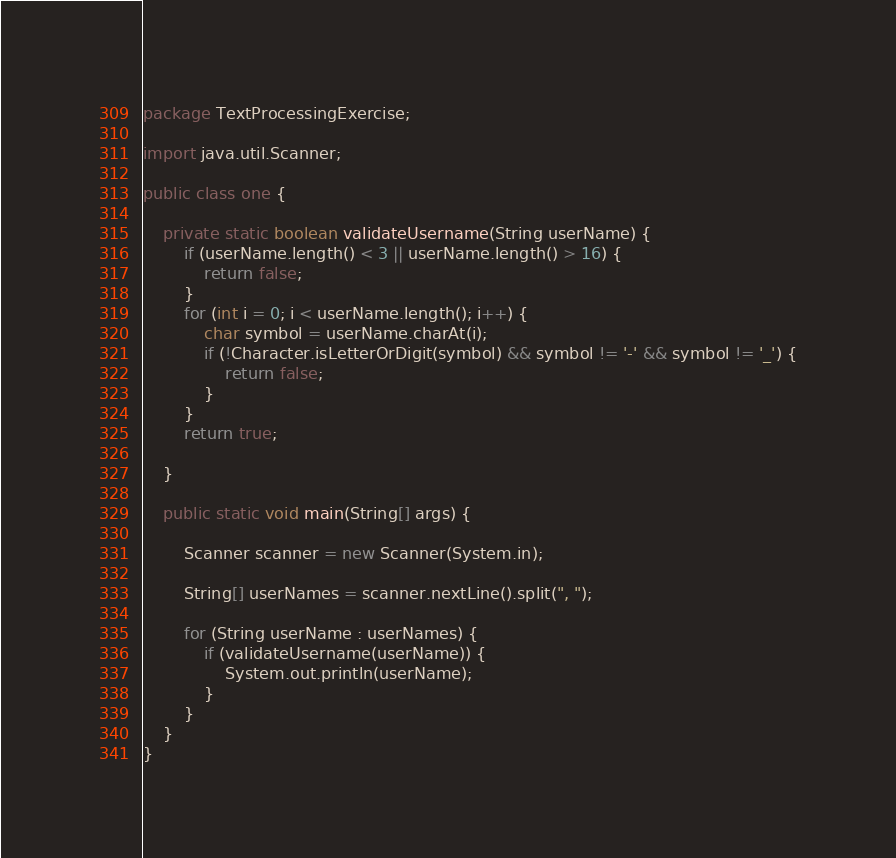<code> <loc_0><loc_0><loc_500><loc_500><_Java_>package TextProcessingExercise;

import java.util.Scanner;

public class one {

    private static boolean validateUsername(String userName) {
        if (userName.length() < 3 || userName.length() > 16) {
            return false;
        }
        for (int i = 0; i < userName.length(); i++) {
            char symbol = userName.charAt(i);
            if (!Character.isLetterOrDigit(symbol) && symbol != '-' && symbol != '_') {
                return false;
            }
        }
        return true;

    }

    public static void main(String[] args) {

        Scanner scanner = new Scanner(System.in);

        String[] userNames = scanner.nextLine().split(", ");

        for (String userName : userNames) {
            if (validateUsername(userName)) {
                System.out.println(userName);
            }
        }
    }
}




</code> 